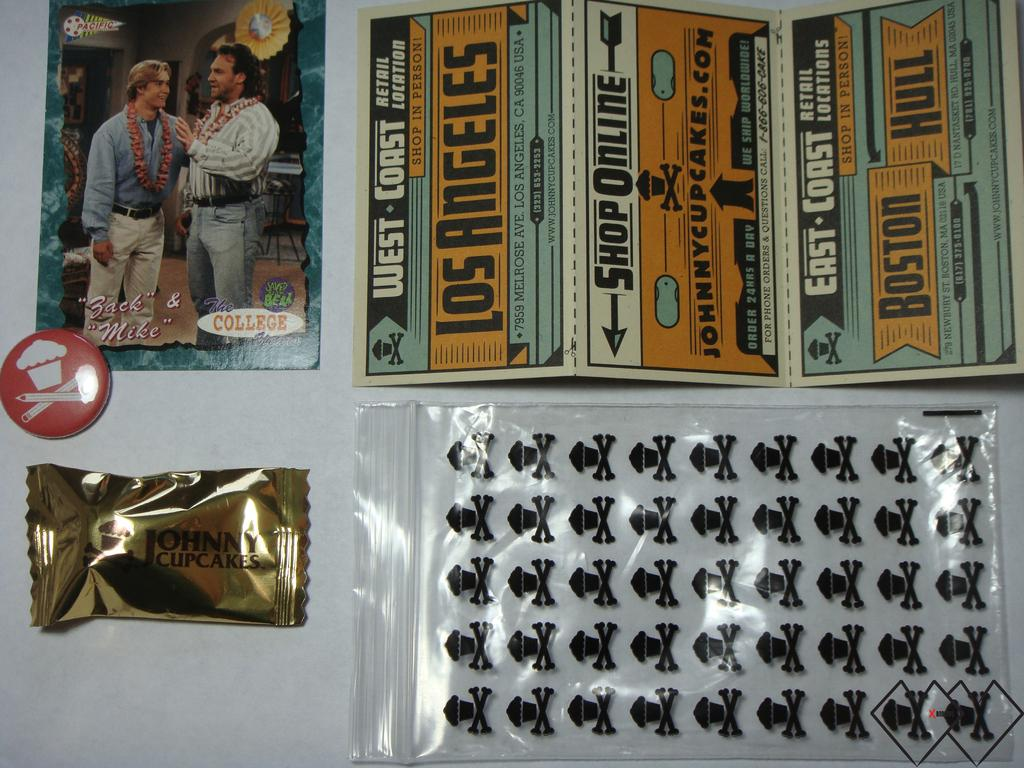How many people are in the image? There are two men in the image. What are the men wearing around their necks? The men are wearing garlands. What type of cover is present in the image? There is a chocolate cover and a plastic cover in the image. What type of record can be seen being played by the men in the image? There is no record or any indication of music playing in the image. 